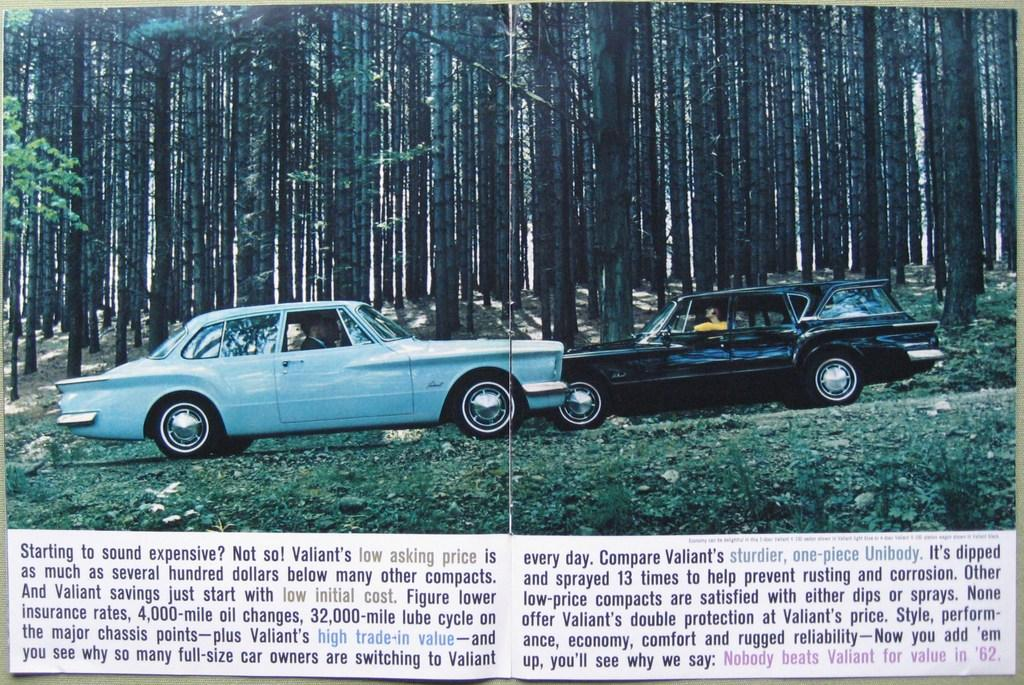What is the main object in the image? There is a paper in the image. What is shown on the paper? Cars are depicted on the paper. What else can be seen in the image besides the paper? There are trees in the image. What is written or printed on the paper? There is text on the paper. Which direction are the cars on the paper facing? The image does not provide information about the direction the cars are facing, as it only shows a depiction of cars on the paper. 